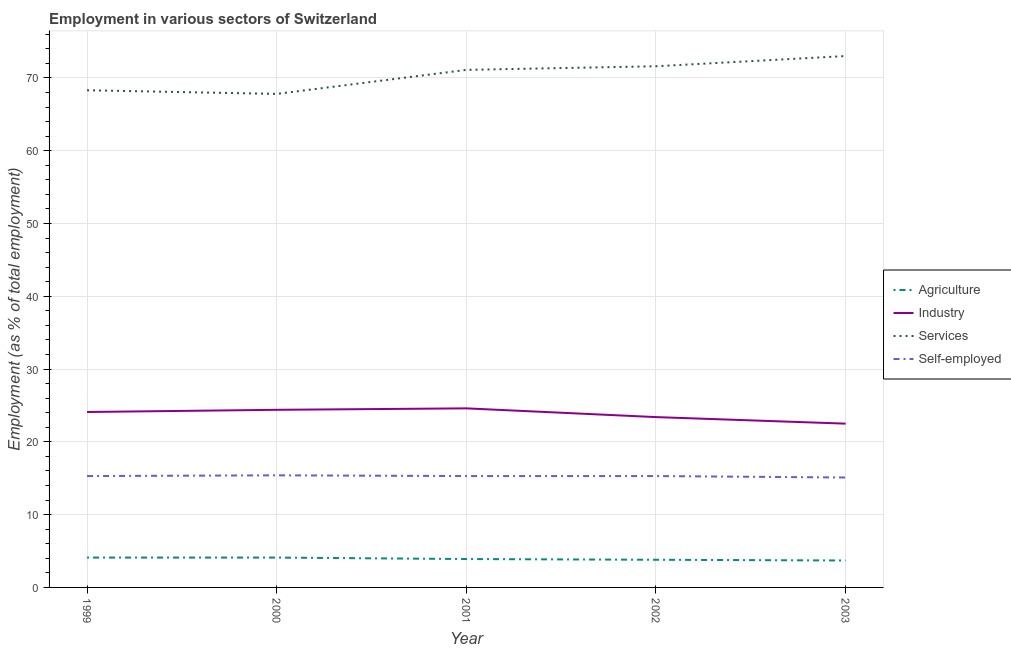How many different coloured lines are there?
Offer a terse response. 4. Does the line corresponding to percentage of self employed workers intersect with the line corresponding to percentage of workers in services?
Your answer should be compact. No. Is the number of lines equal to the number of legend labels?
Make the answer very short. Yes. What is the percentage of workers in agriculture in 2003?
Your response must be concise. 3.7. Across all years, what is the minimum percentage of workers in agriculture?
Keep it short and to the point. 3.7. What is the total percentage of workers in agriculture in the graph?
Your answer should be very brief. 19.6. What is the difference between the percentage of workers in agriculture in 1999 and that in 2000?
Make the answer very short. 0. What is the difference between the percentage of workers in industry in 2002 and the percentage of workers in services in 2001?
Your response must be concise. -47.7. What is the average percentage of workers in agriculture per year?
Your response must be concise. 3.92. In the year 2003, what is the difference between the percentage of workers in industry and percentage of workers in services?
Your answer should be compact. -50.5. What is the ratio of the percentage of workers in services in 2001 to that in 2003?
Provide a succinct answer. 0.97. Is the percentage of workers in services in 2001 less than that in 2003?
Provide a short and direct response. Yes. What is the difference between the highest and the second highest percentage of workers in agriculture?
Ensure brevity in your answer.  0. What is the difference between the highest and the lowest percentage of self employed workers?
Ensure brevity in your answer.  0.3. Is it the case that in every year, the sum of the percentage of workers in agriculture and percentage of workers in services is greater than the sum of percentage of self employed workers and percentage of workers in industry?
Ensure brevity in your answer.  Yes. Does the percentage of self employed workers monotonically increase over the years?
Keep it short and to the point. No. Is the percentage of workers in agriculture strictly greater than the percentage of workers in industry over the years?
Ensure brevity in your answer.  No. Is the percentage of workers in services strictly less than the percentage of self employed workers over the years?
Make the answer very short. No. How many years are there in the graph?
Give a very brief answer. 5. What is the difference between two consecutive major ticks on the Y-axis?
Your response must be concise. 10. Are the values on the major ticks of Y-axis written in scientific E-notation?
Give a very brief answer. No. Does the graph contain any zero values?
Provide a succinct answer. No. Where does the legend appear in the graph?
Your answer should be very brief. Center right. How many legend labels are there?
Keep it short and to the point. 4. What is the title of the graph?
Your response must be concise. Employment in various sectors of Switzerland. Does "SF6 gas" appear as one of the legend labels in the graph?
Your answer should be very brief. No. What is the label or title of the Y-axis?
Offer a terse response. Employment (as % of total employment). What is the Employment (as % of total employment) in Agriculture in 1999?
Offer a terse response. 4.1. What is the Employment (as % of total employment) of Industry in 1999?
Give a very brief answer. 24.1. What is the Employment (as % of total employment) of Services in 1999?
Keep it short and to the point. 68.3. What is the Employment (as % of total employment) of Self-employed in 1999?
Provide a succinct answer. 15.3. What is the Employment (as % of total employment) of Agriculture in 2000?
Your response must be concise. 4.1. What is the Employment (as % of total employment) in Industry in 2000?
Your answer should be very brief. 24.4. What is the Employment (as % of total employment) of Services in 2000?
Give a very brief answer. 67.8. What is the Employment (as % of total employment) in Self-employed in 2000?
Your response must be concise. 15.4. What is the Employment (as % of total employment) in Agriculture in 2001?
Provide a succinct answer. 3.9. What is the Employment (as % of total employment) of Industry in 2001?
Provide a succinct answer. 24.6. What is the Employment (as % of total employment) of Services in 2001?
Provide a short and direct response. 71.1. What is the Employment (as % of total employment) of Self-employed in 2001?
Your answer should be compact. 15.3. What is the Employment (as % of total employment) in Agriculture in 2002?
Ensure brevity in your answer.  3.8. What is the Employment (as % of total employment) in Industry in 2002?
Provide a short and direct response. 23.4. What is the Employment (as % of total employment) in Services in 2002?
Offer a very short reply. 71.6. What is the Employment (as % of total employment) of Self-employed in 2002?
Provide a succinct answer. 15.3. What is the Employment (as % of total employment) of Agriculture in 2003?
Provide a short and direct response. 3.7. What is the Employment (as % of total employment) of Industry in 2003?
Keep it short and to the point. 22.5. What is the Employment (as % of total employment) of Services in 2003?
Keep it short and to the point. 73. What is the Employment (as % of total employment) in Self-employed in 2003?
Make the answer very short. 15.1. Across all years, what is the maximum Employment (as % of total employment) of Agriculture?
Your answer should be compact. 4.1. Across all years, what is the maximum Employment (as % of total employment) in Industry?
Offer a very short reply. 24.6. Across all years, what is the maximum Employment (as % of total employment) in Self-employed?
Your answer should be compact. 15.4. Across all years, what is the minimum Employment (as % of total employment) in Agriculture?
Provide a succinct answer. 3.7. Across all years, what is the minimum Employment (as % of total employment) in Industry?
Make the answer very short. 22.5. Across all years, what is the minimum Employment (as % of total employment) in Services?
Your answer should be compact. 67.8. Across all years, what is the minimum Employment (as % of total employment) in Self-employed?
Ensure brevity in your answer.  15.1. What is the total Employment (as % of total employment) in Agriculture in the graph?
Your answer should be compact. 19.6. What is the total Employment (as % of total employment) of Industry in the graph?
Your answer should be compact. 119. What is the total Employment (as % of total employment) in Services in the graph?
Make the answer very short. 351.8. What is the total Employment (as % of total employment) in Self-employed in the graph?
Provide a short and direct response. 76.4. What is the difference between the Employment (as % of total employment) in Agriculture in 1999 and that in 2000?
Offer a terse response. 0. What is the difference between the Employment (as % of total employment) in Industry in 1999 and that in 2000?
Your answer should be very brief. -0.3. What is the difference between the Employment (as % of total employment) of Services in 1999 and that in 2000?
Provide a short and direct response. 0.5. What is the difference between the Employment (as % of total employment) of Services in 1999 and that in 2001?
Your response must be concise. -2.8. What is the difference between the Employment (as % of total employment) of Agriculture in 1999 and that in 2002?
Your answer should be compact. 0.3. What is the difference between the Employment (as % of total employment) of Industry in 1999 and that in 2003?
Offer a very short reply. 1.6. What is the difference between the Employment (as % of total employment) in Services in 2000 and that in 2001?
Your response must be concise. -3.3. What is the difference between the Employment (as % of total employment) of Industry in 2000 and that in 2002?
Offer a very short reply. 1. What is the difference between the Employment (as % of total employment) in Services in 2000 and that in 2002?
Ensure brevity in your answer.  -3.8. What is the difference between the Employment (as % of total employment) of Self-employed in 2000 and that in 2002?
Offer a terse response. 0.1. What is the difference between the Employment (as % of total employment) in Services in 2000 and that in 2003?
Keep it short and to the point. -5.2. What is the difference between the Employment (as % of total employment) in Services in 2001 and that in 2003?
Make the answer very short. -1.9. What is the difference between the Employment (as % of total employment) in Agriculture in 2002 and that in 2003?
Your answer should be very brief. 0.1. What is the difference between the Employment (as % of total employment) of Self-employed in 2002 and that in 2003?
Keep it short and to the point. 0.2. What is the difference between the Employment (as % of total employment) of Agriculture in 1999 and the Employment (as % of total employment) of Industry in 2000?
Ensure brevity in your answer.  -20.3. What is the difference between the Employment (as % of total employment) in Agriculture in 1999 and the Employment (as % of total employment) in Services in 2000?
Give a very brief answer. -63.7. What is the difference between the Employment (as % of total employment) in Agriculture in 1999 and the Employment (as % of total employment) in Self-employed in 2000?
Keep it short and to the point. -11.3. What is the difference between the Employment (as % of total employment) of Industry in 1999 and the Employment (as % of total employment) of Services in 2000?
Give a very brief answer. -43.7. What is the difference between the Employment (as % of total employment) of Services in 1999 and the Employment (as % of total employment) of Self-employed in 2000?
Offer a terse response. 52.9. What is the difference between the Employment (as % of total employment) of Agriculture in 1999 and the Employment (as % of total employment) of Industry in 2001?
Ensure brevity in your answer.  -20.5. What is the difference between the Employment (as % of total employment) of Agriculture in 1999 and the Employment (as % of total employment) of Services in 2001?
Make the answer very short. -67. What is the difference between the Employment (as % of total employment) of Industry in 1999 and the Employment (as % of total employment) of Services in 2001?
Offer a very short reply. -47. What is the difference between the Employment (as % of total employment) in Services in 1999 and the Employment (as % of total employment) in Self-employed in 2001?
Keep it short and to the point. 53. What is the difference between the Employment (as % of total employment) of Agriculture in 1999 and the Employment (as % of total employment) of Industry in 2002?
Provide a succinct answer. -19.3. What is the difference between the Employment (as % of total employment) of Agriculture in 1999 and the Employment (as % of total employment) of Services in 2002?
Your answer should be compact. -67.5. What is the difference between the Employment (as % of total employment) of Industry in 1999 and the Employment (as % of total employment) of Services in 2002?
Keep it short and to the point. -47.5. What is the difference between the Employment (as % of total employment) of Industry in 1999 and the Employment (as % of total employment) of Self-employed in 2002?
Offer a very short reply. 8.8. What is the difference between the Employment (as % of total employment) in Services in 1999 and the Employment (as % of total employment) in Self-employed in 2002?
Your response must be concise. 53. What is the difference between the Employment (as % of total employment) in Agriculture in 1999 and the Employment (as % of total employment) in Industry in 2003?
Make the answer very short. -18.4. What is the difference between the Employment (as % of total employment) of Agriculture in 1999 and the Employment (as % of total employment) of Services in 2003?
Give a very brief answer. -68.9. What is the difference between the Employment (as % of total employment) of Industry in 1999 and the Employment (as % of total employment) of Services in 2003?
Give a very brief answer. -48.9. What is the difference between the Employment (as % of total employment) in Industry in 1999 and the Employment (as % of total employment) in Self-employed in 2003?
Provide a short and direct response. 9. What is the difference between the Employment (as % of total employment) in Services in 1999 and the Employment (as % of total employment) in Self-employed in 2003?
Offer a very short reply. 53.2. What is the difference between the Employment (as % of total employment) of Agriculture in 2000 and the Employment (as % of total employment) of Industry in 2001?
Offer a terse response. -20.5. What is the difference between the Employment (as % of total employment) in Agriculture in 2000 and the Employment (as % of total employment) in Services in 2001?
Give a very brief answer. -67. What is the difference between the Employment (as % of total employment) in Agriculture in 2000 and the Employment (as % of total employment) in Self-employed in 2001?
Ensure brevity in your answer.  -11.2. What is the difference between the Employment (as % of total employment) of Industry in 2000 and the Employment (as % of total employment) of Services in 2001?
Your answer should be compact. -46.7. What is the difference between the Employment (as % of total employment) of Services in 2000 and the Employment (as % of total employment) of Self-employed in 2001?
Offer a very short reply. 52.5. What is the difference between the Employment (as % of total employment) of Agriculture in 2000 and the Employment (as % of total employment) of Industry in 2002?
Keep it short and to the point. -19.3. What is the difference between the Employment (as % of total employment) in Agriculture in 2000 and the Employment (as % of total employment) in Services in 2002?
Offer a terse response. -67.5. What is the difference between the Employment (as % of total employment) of Agriculture in 2000 and the Employment (as % of total employment) of Self-employed in 2002?
Your answer should be compact. -11.2. What is the difference between the Employment (as % of total employment) in Industry in 2000 and the Employment (as % of total employment) in Services in 2002?
Provide a succinct answer. -47.2. What is the difference between the Employment (as % of total employment) in Industry in 2000 and the Employment (as % of total employment) in Self-employed in 2002?
Make the answer very short. 9.1. What is the difference between the Employment (as % of total employment) of Services in 2000 and the Employment (as % of total employment) of Self-employed in 2002?
Make the answer very short. 52.5. What is the difference between the Employment (as % of total employment) of Agriculture in 2000 and the Employment (as % of total employment) of Industry in 2003?
Give a very brief answer. -18.4. What is the difference between the Employment (as % of total employment) in Agriculture in 2000 and the Employment (as % of total employment) in Services in 2003?
Give a very brief answer. -68.9. What is the difference between the Employment (as % of total employment) of Industry in 2000 and the Employment (as % of total employment) of Services in 2003?
Provide a succinct answer. -48.6. What is the difference between the Employment (as % of total employment) of Industry in 2000 and the Employment (as % of total employment) of Self-employed in 2003?
Give a very brief answer. 9.3. What is the difference between the Employment (as % of total employment) of Services in 2000 and the Employment (as % of total employment) of Self-employed in 2003?
Keep it short and to the point. 52.7. What is the difference between the Employment (as % of total employment) of Agriculture in 2001 and the Employment (as % of total employment) of Industry in 2002?
Offer a very short reply. -19.5. What is the difference between the Employment (as % of total employment) of Agriculture in 2001 and the Employment (as % of total employment) of Services in 2002?
Your answer should be compact. -67.7. What is the difference between the Employment (as % of total employment) in Agriculture in 2001 and the Employment (as % of total employment) in Self-employed in 2002?
Provide a short and direct response. -11.4. What is the difference between the Employment (as % of total employment) of Industry in 2001 and the Employment (as % of total employment) of Services in 2002?
Provide a short and direct response. -47. What is the difference between the Employment (as % of total employment) of Services in 2001 and the Employment (as % of total employment) of Self-employed in 2002?
Offer a very short reply. 55.8. What is the difference between the Employment (as % of total employment) in Agriculture in 2001 and the Employment (as % of total employment) in Industry in 2003?
Your answer should be compact. -18.6. What is the difference between the Employment (as % of total employment) of Agriculture in 2001 and the Employment (as % of total employment) of Services in 2003?
Offer a terse response. -69.1. What is the difference between the Employment (as % of total employment) of Industry in 2001 and the Employment (as % of total employment) of Services in 2003?
Your answer should be very brief. -48.4. What is the difference between the Employment (as % of total employment) in Agriculture in 2002 and the Employment (as % of total employment) in Industry in 2003?
Provide a short and direct response. -18.7. What is the difference between the Employment (as % of total employment) in Agriculture in 2002 and the Employment (as % of total employment) in Services in 2003?
Make the answer very short. -69.2. What is the difference between the Employment (as % of total employment) of Agriculture in 2002 and the Employment (as % of total employment) of Self-employed in 2003?
Ensure brevity in your answer.  -11.3. What is the difference between the Employment (as % of total employment) in Industry in 2002 and the Employment (as % of total employment) in Services in 2003?
Provide a succinct answer. -49.6. What is the difference between the Employment (as % of total employment) of Industry in 2002 and the Employment (as % of total employment) of Self-employed in 2003?
Your response must be concise. 8.3. What is the difference between the Employment (as % of total employment) of Services in 2002 and the Employment (as % of total employment) of Self-employed in 2003?
Offer a terse response. 56.5. What is the average Employment (as % of total employment) in Agriculture per year?
Make the answer very short. 3.92. What is the average Employment (as % of total employment) of Industry per year?
Your response must be concise. 23.8. What is the average Employment (as % of total employment) in Services per year?
Make the answer very short. 70.36. What is the average Employment (as % of total employment) of Self-employed per year?
Your answer should be very brief. 15.28. In the year 1999, what is the difference between the Employment (as % of total employment) of Agriculture and Employment (as % of total employment) of Services?
Provide a succinct answer. -64.2. In the year 1999, what is the difference between the Employment (as % of total employment) in Agriculture and Employment (as % of total employment) in Self-employed?
Make the answer very short. -11.2. In the year 1999, what is the difference between the Employment (as % of total employment) in Industry and Employment (as % of total employment) in Services?
Your answer should be compact. -44.2. In the year 1999, what is the difference between the Employment (as % of total employment) in Industry and Employment (as % of total employment) in Self-employed?
Provide a succinct answer. 8.8. In the year 1999, what is the difference between the Employment (as % of total employment) of Services and Employment (as % of total employment) of Self-employed?
Keep it short and to the point. 53. In the year 2000, what is the difference between the Employment (as % of total employment) in Agriculture and Employment (as % of total employment) in Industry?
Your answer should be compact. -20.3. In the year 2000, what is the difference between the Employment (as % of total employment) of Agriculture and Employment (as % of total employment) of Services?
Your answer should be very brief. -63.7. In the year 2000, what is the difference between the Employment (as % of total employment) of Agriculture and Employment (as % of total employment) of Self-employed?
Provide a short and direct response. -11.3. In the year 2000, what is the difference between the Employment (as % of total employment) in Industry and Employment (as % of total employment) in Services?
Offer a terse response. -43.4. In the year 2000, what is the difference between the Employment (as % of total employment) of Industry and Employment (as % of total employment) of Self-employed?
Your answer should be very brief. 9. In the year 2000, what is the difference between the Employment (as % of total employment) in Services and Employment (as % of total employment) in Self-employed?
Give a very brief answer. 52.4. In the year 2001, what is the difference between the Employment (as % of total employment) in Agriculture and Employment (as % of total employment) in Industry?
Your answer should be compact. -20.7. In the year 2001, what is the difference between the Employment (as % of total employment) in Agriculture and Employment (as % of total employment) in Services?
Keep it short and to the point. -67.2. In the year 2001, what is the difference between the Employment (as % of total employment) in Agriculture and Employment (as % of total employment) in Self-employed?
Make the answer very short. -11.4. In the year 2001, what is the difference between the Employment (as % of total employment) in Industry and Employment (as % of total employment) in Services?
Ensure brevity in your answer.  -46.5. In the year 2001, what is the difference between the Employment (as % of total employment) of Industry and Employment (as % of total employment) of Self-employed?
Offer a terse response. 9.3. In the year 2001, what is the difference between the Employment (as % of total employment) in Services and Employment (as % of total employment) in Self-employed?
Provide a succinct answer. 55.8. In the year 2002, what is the difference between the Employment (as % of total employment) of Agriculture and Employment (as % of total employment) of Industry?
Offer a very short reply. -19.6. In the year 2002, what is the difference between the Employment (as % of total employment) in Agriculture and Employment (as % of total employment) in Services?
Provide a succinct answer. -67.8. In the year 2002, what is the difference between the Employment (as % of total employment) in Agriculture and Employment (as % of total employment) in Self-employed?
Offer a very short reply. -11.5. In the year 2002, what is the difference between the Employment (as % of total employment) in Industry and Employment (as % of total employment) in Services?
Provide a short and direct response. -48.2. In the year 2002, what is the difference between the Employment (as % of total employment) in Services and Employment (as % of total employment) in Self-employed?
Ensure brevity in your answer.  56.3. In the year 2003, what is the difference between the Employment (as % of total employment) in Agriculture and Employment (as % of total employment) in Industry?
Provide a succinct answer. -18.8. In the year 2003, what is the difference between the Employment (as % of total employment) of Agriculture and Employment (as % of total employment) of Services?
Keep it short and to the point. -69.3. In the year 2003, what is the difference between the Employment (as % of total employment) in Agriculture and Employment (as % of total employment) in Self-employed?
Keep it short and to the point. -11.4. In the year 2003, what is the difference between the Employment (as % of total employment) in Industry and Employment (as % of total employment) in Services?
Keep it short and to the point. -50.5. In the year 2003, what is the difference between the Employment (as % of total employment) of Industry and Employment (as % of total employment) of Self-employed?
Offer a terse response. 7.4. In the year 2003, what is the difference between the Employment (as % of total employment) of Services and Employment (as % of total employment) of Self-employed?
Your answer should be compact. 57.9. What is the ratio of the Employment (as % of total employment) in Agriculture in 1999 to that in 2000?
Give a very brief answer. 1. What is the ratio of the Employment (as % of total employment) of Industry in 1999 to that in 2000?
Give a very brief answer. 0.99. What is the ratio of the Employment (as % of total employment) of Services in 1999 to that in 2000?
Your answer should be very brief. 1.01. What is the ratio of the Employment (as % of total employment) in Self-employed in 1999 to that in 2000?
Your response must be concise. 0.99. What is the ratio of the Employment (as % of total employment) of Agriculture in 1999 to that in 2001?
Make the answer very short. 1.05. What is the ratio of the Employment (as % of total employment) in Industry in 1999 to that in 2001?
Offer a very short reply. 0.98. What is the ratio of the Employment (as % of total employment) of Services in 1999 to that in 2001?
Your answer should be compact. 0.96. What is the ratio of the Employment (as % of total employment) in Self-employed in 1999 to that in 2001?
Keep it short and to the point. 1. What is the ratio of the Employment (as % of total employment) in Agriculture in 1999 to that in 2002?
Ensure brevity in your answer.  1.08. What is the ratio of the Employment (as % of total employment) of Industry in 1999 to that in 2002?
Offer a terse response. 1.03. What is the ratio of the Employment (as % of total employment) of Services in 1999 to that in 2002?
Provide a short and direct response. 0.95. What is the ratio of the Employment (as % of total employment) in Agriculture in 1999 to that in 2003?
Your answer should be compact. 1.11. What is the ratio of the Employment (as % of total employment) of Industry in 1999 to that in 2003?
Make the answer very short. 1.07. What is the ratio of the Employment (as % of total employment) of Services in 1999 to that in 2003?
Make the answer very short. 0.94. What is the ratio of the Employment (as % of total employment) of Self-employed in 1999 to that in 2003?
Offer a terse response. 1.01. What is the ratio of the Employment (as % of total employment) in Agriculture in 2000 to that in 2001?
Give a very brief answer. 1.05. What is the ratio of the Employment (as % of total employment) in Industry in 2000 to that in 2001?
Make the answer very short. 0.99. What is the ratio of the Employment (as % of total employment) in Services in 2000 to that in 2001?
Your response must be concise. 0.95. What is the ratio of the Employment (as % of total employment) in Agriculture in 2000 to that in 2002?
Provide a short and direct response. 1.08. What is the ratio of the Employment (as % of total employment) of Industry in 2000 to that in 2002?
Your response must be concise. 1.04. What is the ratio of the Employment (as % of total employment) in Services in 2000 to that in 2002?
Your response must be concise. 0.95. What is the ratio of the Employment (as % of total employment) of Agriculture in 2000 to that in 2003?
Provide a succinct answer. 1.11. What is the ratio of the Employment (as % of total employment) of Industry in 2000 to that in 2003?
Your answer should be compact. 1.08. What is the ratio of the Employment (as % of total employment) of Services in 2000 to that in 2003?
Your answer should be compact. 0.93. What is the ratio of the Employment (as % of total employment) of Self-employed in 2000 to that in 2003?
Keep it short and to the point. 1.02. What is the ratio of the Employment (as % of total employment) in Agriculture in 2001 to that in 2002?
Give a very brief answer. 1.03. What is the ratio of the Employment (as % of total employment) in Industry in 2001 to that in 2002?
Offer a terse response. 1.05. What is the ratio of the Employment (as % of total employment) in Self-employed in 2001 to that in 2002?
Offer a terse response. 1. What is the ratio of the Employment (as % of total employment) of Agriculture in 2001 to that in 2003?
Ensure brevity in your answer.  1.05. What is the ratio of the Employment (as % of total employment) of Industry in 2001 to that in 2003?
Keep it short and to the point. 1.09. What is the ratio of the Employment (as % of total employment) in Self-employed in 2001 to that in 2003?
Your response must be concise. 1.01. What is the ratio of the Employment (as % of total employment) of Industry in 2002 to that in 2003?
Your response must be concise. 1.04. What is the ratio of the Employment (as % of total employment) of Services in 2002 to that in 2003?
Your answer should be compact. 0.98. What is the ratio of the Employment (as % of total employment) of Self-employed in 2002 to that in 2003?
Ensure brevity in your answer.  1.01. What is the difference between the highest and the lowest Employment (as % of total employment) of Agriculture?
Make the answer very short. 0.4. What is the difference between the highest and the lowest Employment (as % of total employment) in Industry?
Offer a very short reply. 2.1. What is the difference between the highest and the lowest Employment (as % of total employment) in Services?
Your answer should be very brief. 5.2. 